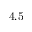Convert formula to latex. <formula><loc_0><loc_0><loc_500><loc_500>4 . 5</formula> 